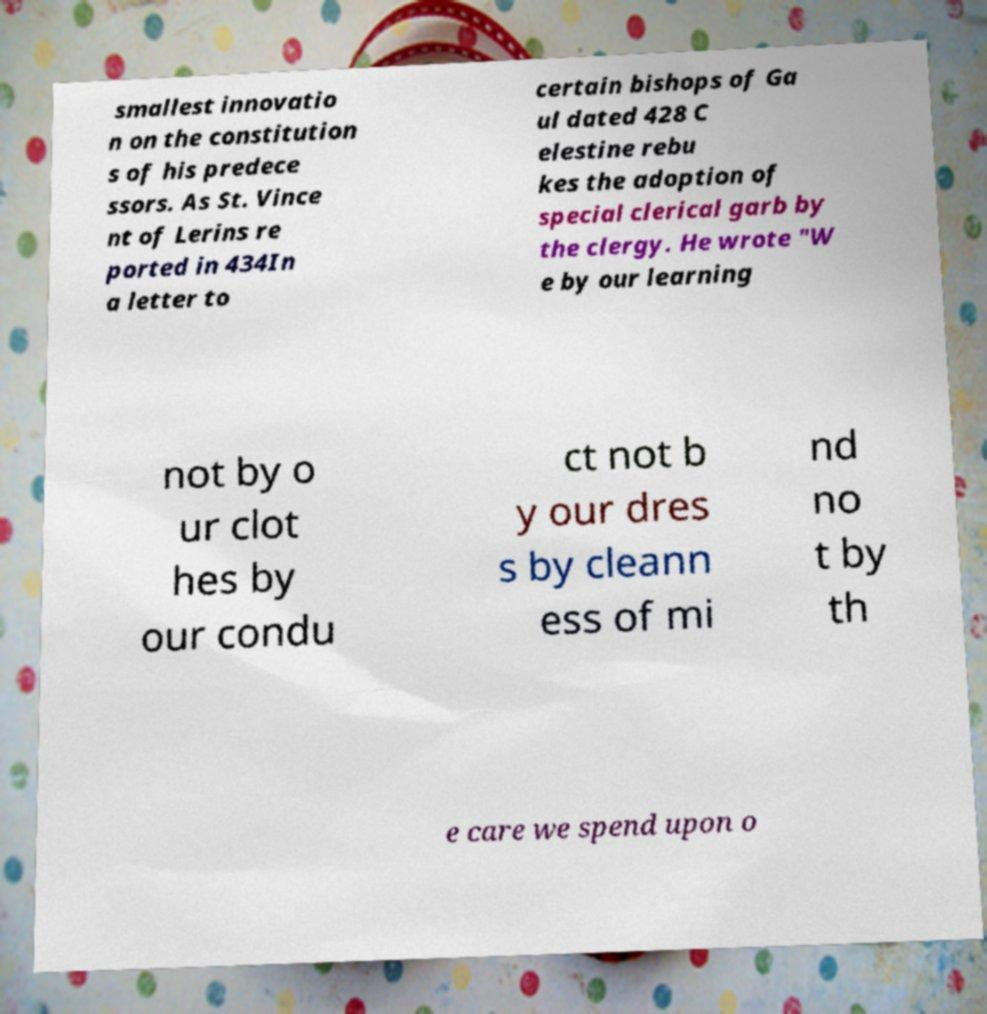There's text embedded in this image that I need extracted. Can you transcribe it verbatim? smallest innovatio n on the constitution s of his predece ssors. As St. Vince nt of Lerins re ported in 434In a letter to certain bishops of Ga ul dated 428 C elestine rebu kes the adoption of special clerical garb by the clergy. He wrote "W e by our learning not by o ur clot hes by our condu ct not b y our dres s by cleann ess of mi nd no t by th e care we spend upon o 